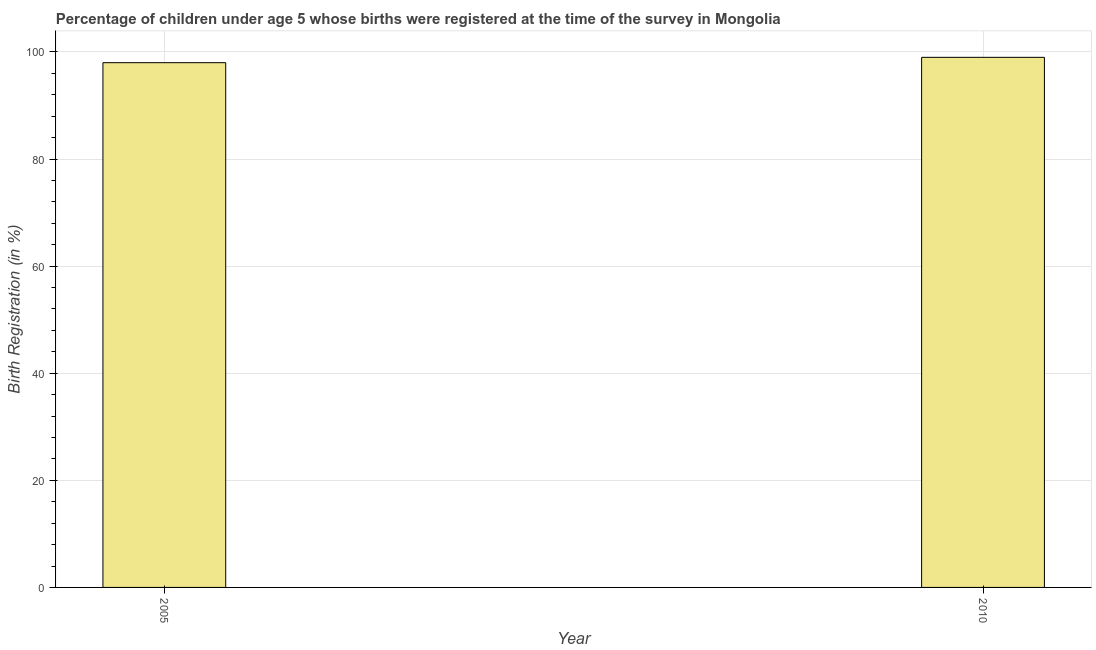Does the graph contain any zero values?
Keep it short and to the point. No. What is the title of the graph?
Ensure brevity in your answer.  Percentage of children under age 5 whose births were registered at the time of the survey in Mongolia. What is the label or title of the X-axis?
Provide a short and direct response. Year. What is the label or title of the Y-axis?
Provide a short and direct response. Birth Registration (in %). What is the birth registration in 2010?
Your response must be concise. 99. Across all years, what is the maximum birth registration?
Your answer should be very brief. 99. In which year was the birth registration maximum?
Your answer should be compact. 2010. In which year was the birth registration minimum?
Provide a succinct answer. 2005. What is the sum of the birth registration?
Ensure brevity in your answer.  197. What is the median birth registration?
Keep it short and to the point. 98.5. Do a majority of the years between 2010 and 2005 (inclusive) have birth registration greater than 64 %?
Your answer should be compact. No. Is the birth registration in 2005 less than that in 2010?
Your response must be concise. Yes. In how many years, is the birth registration greater than the average birth registration taken over all years?
Provide a short and direct response. 1. Are all the bars in the graph horizontal?
Your answer should be very brief. No. How many years are there in the graph?
Your answer should be very brief. 2. What is the difference between two consecutive major ticks on the Y-axis?
Provide a succinct answer. 20. Are the values on the major ticks of Y-axis written in scientific E-notation?
Keep it short and to the point. No. What is the difference between the Birth Registration (in %) in 2005 and 2010?
Provide a short and direct response. -1. What is the ratio of the Birth Registration (in %) in 2005 to that in 2010?
Provide a succinct answer. 0.99. 